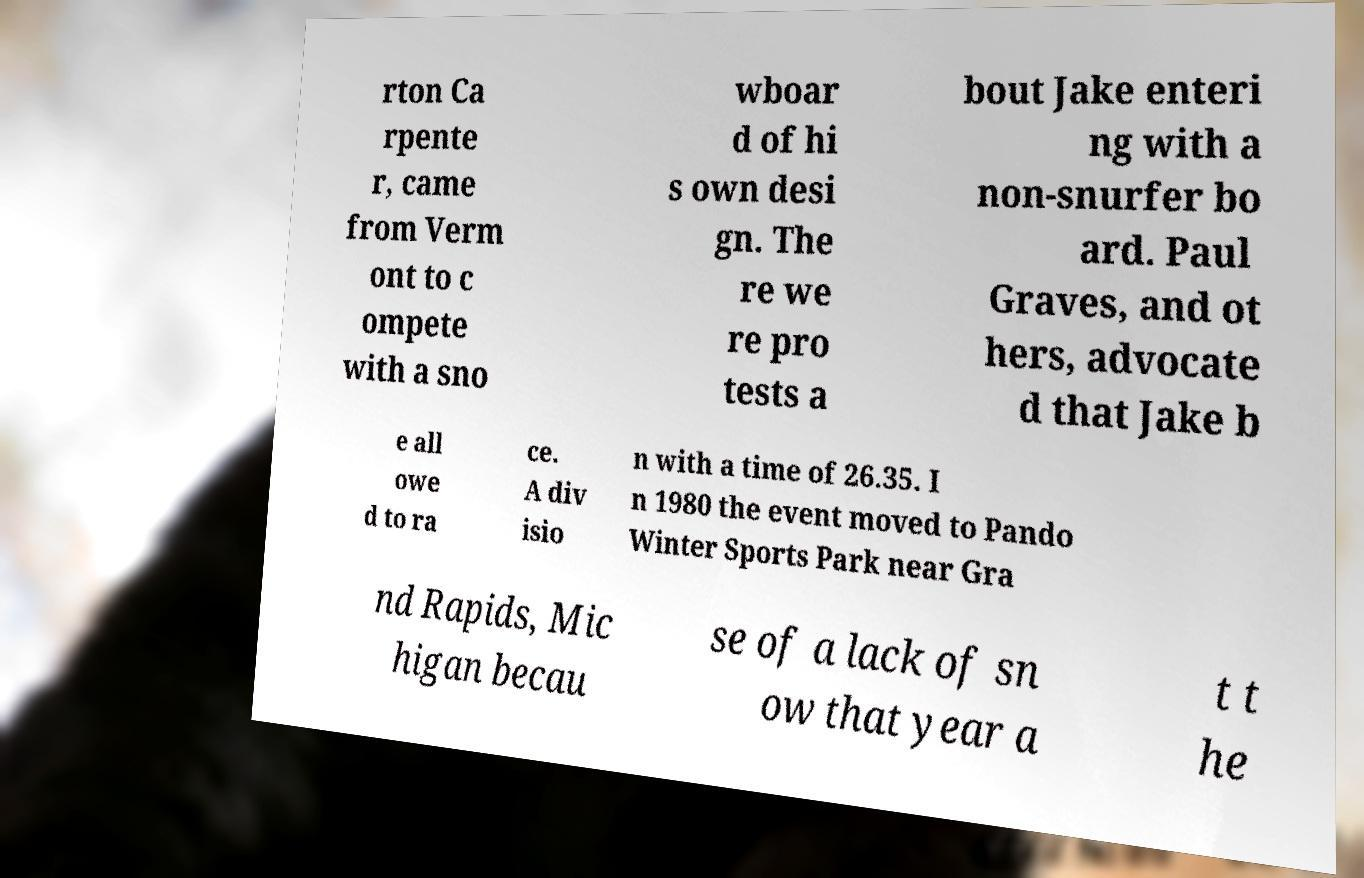What messages or text are displayed in this image? I need them in a readable, typed format. rton Ca rpente r, came from Verm ont to c ompete with a sno wboar d of hi s own desi gn. The re we re pro tests a bout Jake enteri ng with a non-snurfer bo ard. Paul Graves, and ot hers, advocate d that Jake b e all owe d to ra ce. A div isio n with a time of 26.35. I n 1980 the event moved to Pando Winter Sports Park near Gra nd Rapids, Mic higan becau se of a lack of sn ow that year a t t he 